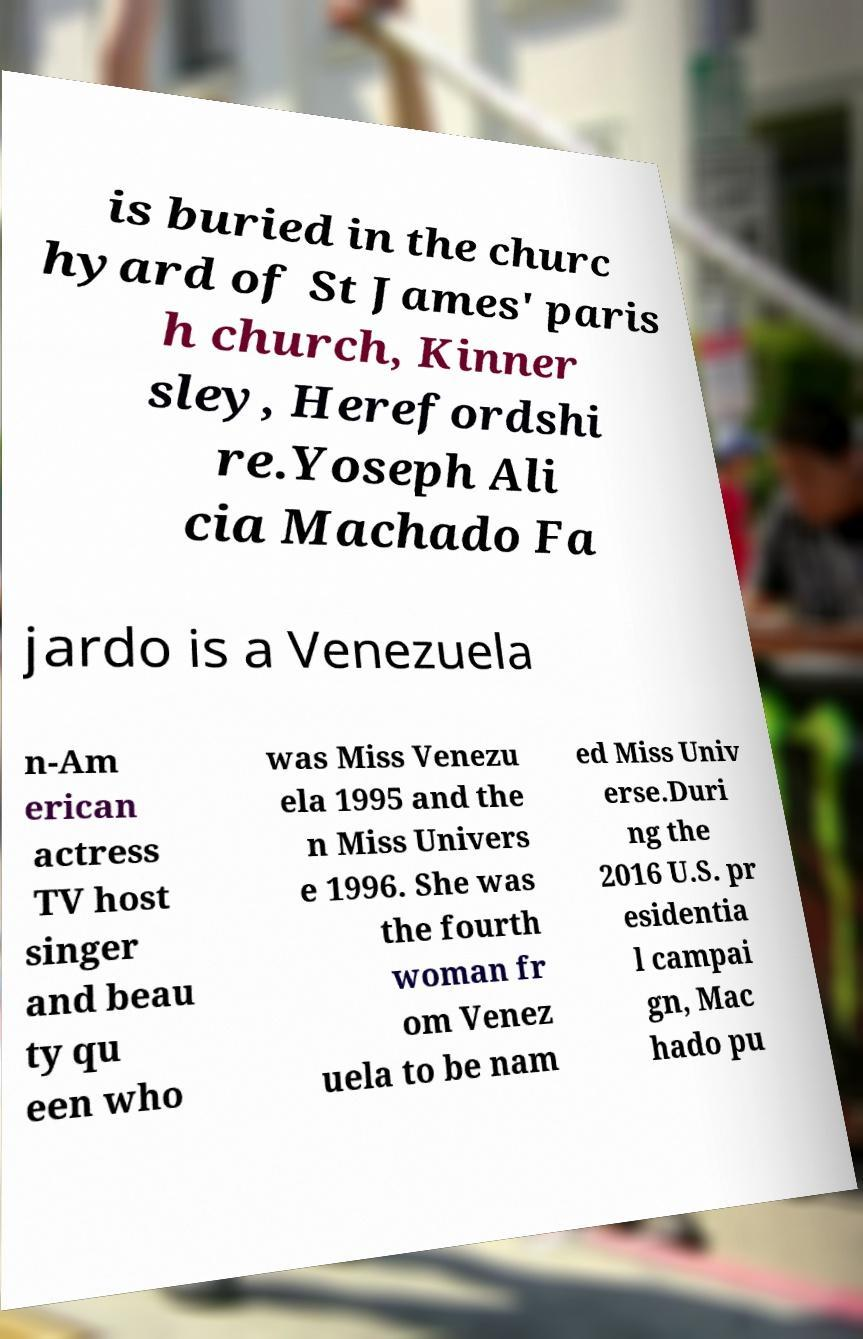Could you extract and type out the text from this image? is buried in the churc hyard of St James' paris h church, Kinner sley, Herefordshi re.Yoseph Ali cia Machado Fa jardo is a Venezuela n-Am erican actress TV host singer and beau ty qu een who was Miss Venezu ela 1995 and the n Miss Univers e 1996. She was the fourth woman fr om Venez uela to be nam ed Miss Univ erse.Duri ng the 2016 U.S. pr esidentia l campai gn, Mac hado pu 